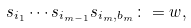<formula> <loc_0><loc_0><loc_500><loc_500>s _ { i _ { 1 } } \cdots s _ { i _ { m - 1 } } s _ { i _ { m } , b _ { m } } \colon = w ,</formula> 